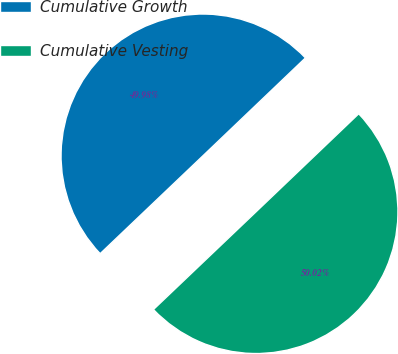Convert chart to OTSL. <chart><loc_0><loc_0><loc_500><loc_500><pie_chart><fcel>Cumulative Growth<fcel>Cumulative Vesting<nl><fcel>49.98%<fcel>50.02%<nl></chart> 